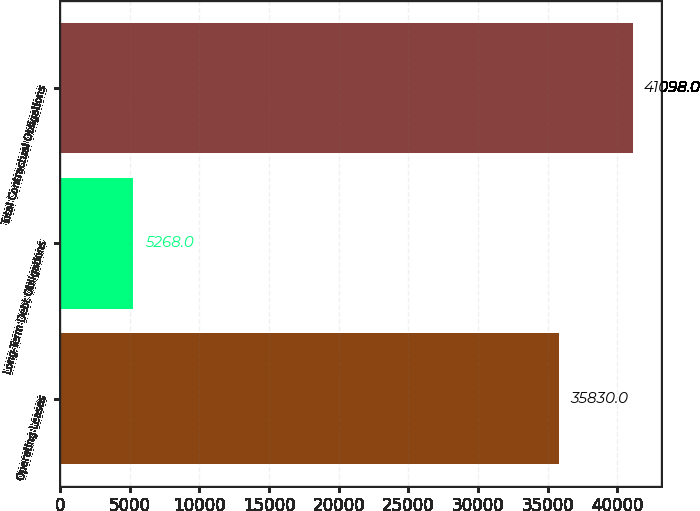Convert chart to OTSL. <chart><loc_0><loc_0><loc_500><loc_500><bar_chart><fcel>Operating Leases<fcel>Long-Term Debt Obligations<fcel>Total Contractual Obligations<nl><fcel>35830<fcel>5268<fcel>41098<nl></chart> 